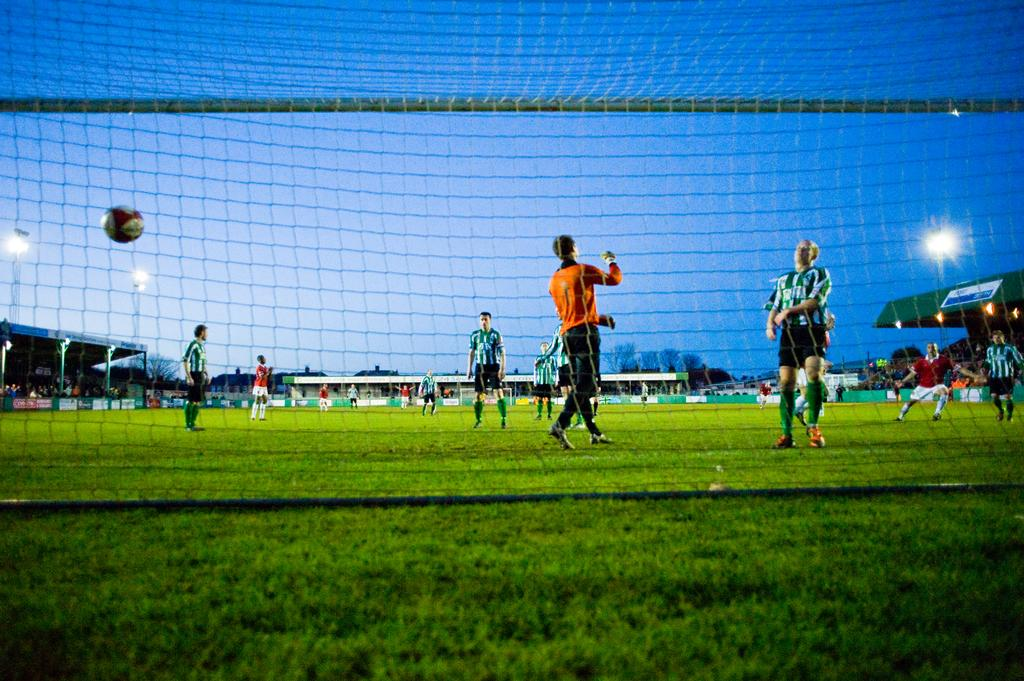What are the persons in the image doing? The persons in the image are playing on the ground. What is the surface they are playing on? The ground is covered with grass. What object can be seen in the image that is commonly used in games? There is a ball in the image. What structure is visible in the image that might be used for sports or games? There is a mesh in the image. What can be seen in the background of the image that might indicate a sports facility or play area? There are boards, sheds, lights, and trees in the background of the image. What is visible in the background of the image that indicates the time of day or weather conditions? The sky is visible in the background of the image. What type of tray is being used by the owner of the ball in the image? There is no tray or owner of the ball mentioned in the image. How does the disgust of the players affect their performance in the game? There is no indication of disgust or any emotional state of the players in the image. 